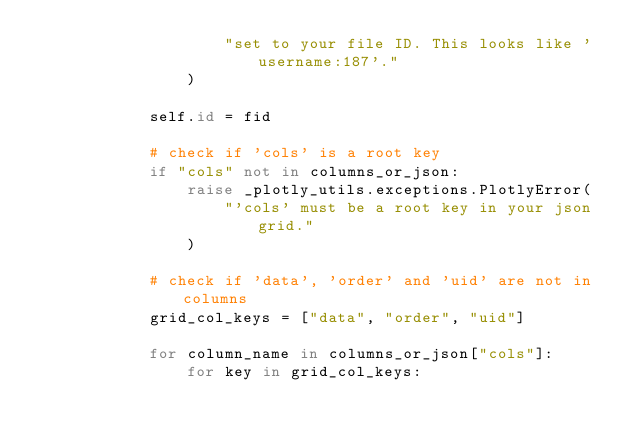Convert code to text. <code><loc_0><loc_0><loc_500><loc_500><_Python_>                    "set to your file ID. This looks like 'username:187'."
                )

            self.id = fid

            # check if 'cols' is a root key
            if "cols" not in columns_or_json:
                raise _plotly_utils.exceptions.PlotlyError(
                    "'cols' must be a root key in your json grid."
                )

            # check if 'data', 'order' and 'uid' are not in columns
            grid_col_keys = ["data", "order", "uid"]

            for column_name in columns_or_json["cols"]:
                for key in grid_col_keys:</code> 